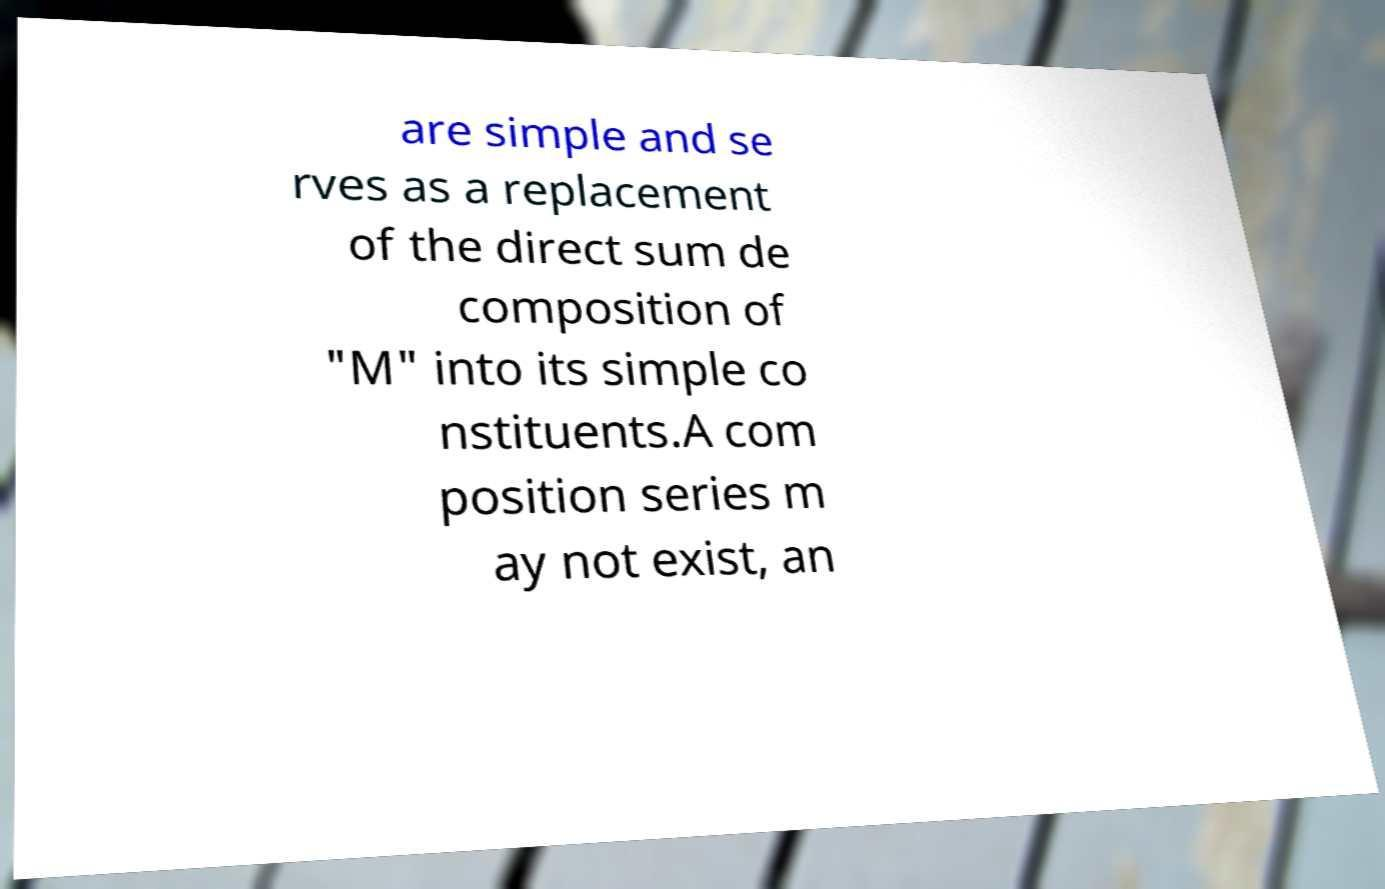Could you assist in decoding the text presented in this image and type it out clearly? are simple and se rves as a replacement of the direct sum de composition of "M" into its simple co nstituents.A com position series m ay not exist, an 